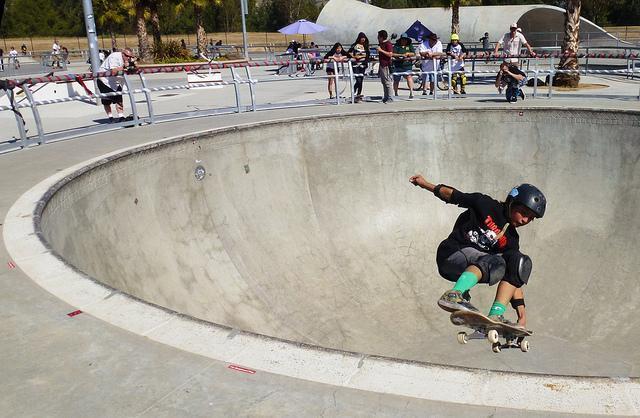How many people are skating?
Give a very brief answer. 1. How many people are in the picture?
Give a very brief answer. 3. How many chairs are shown around the table?
Give a very brief answer. 0. 